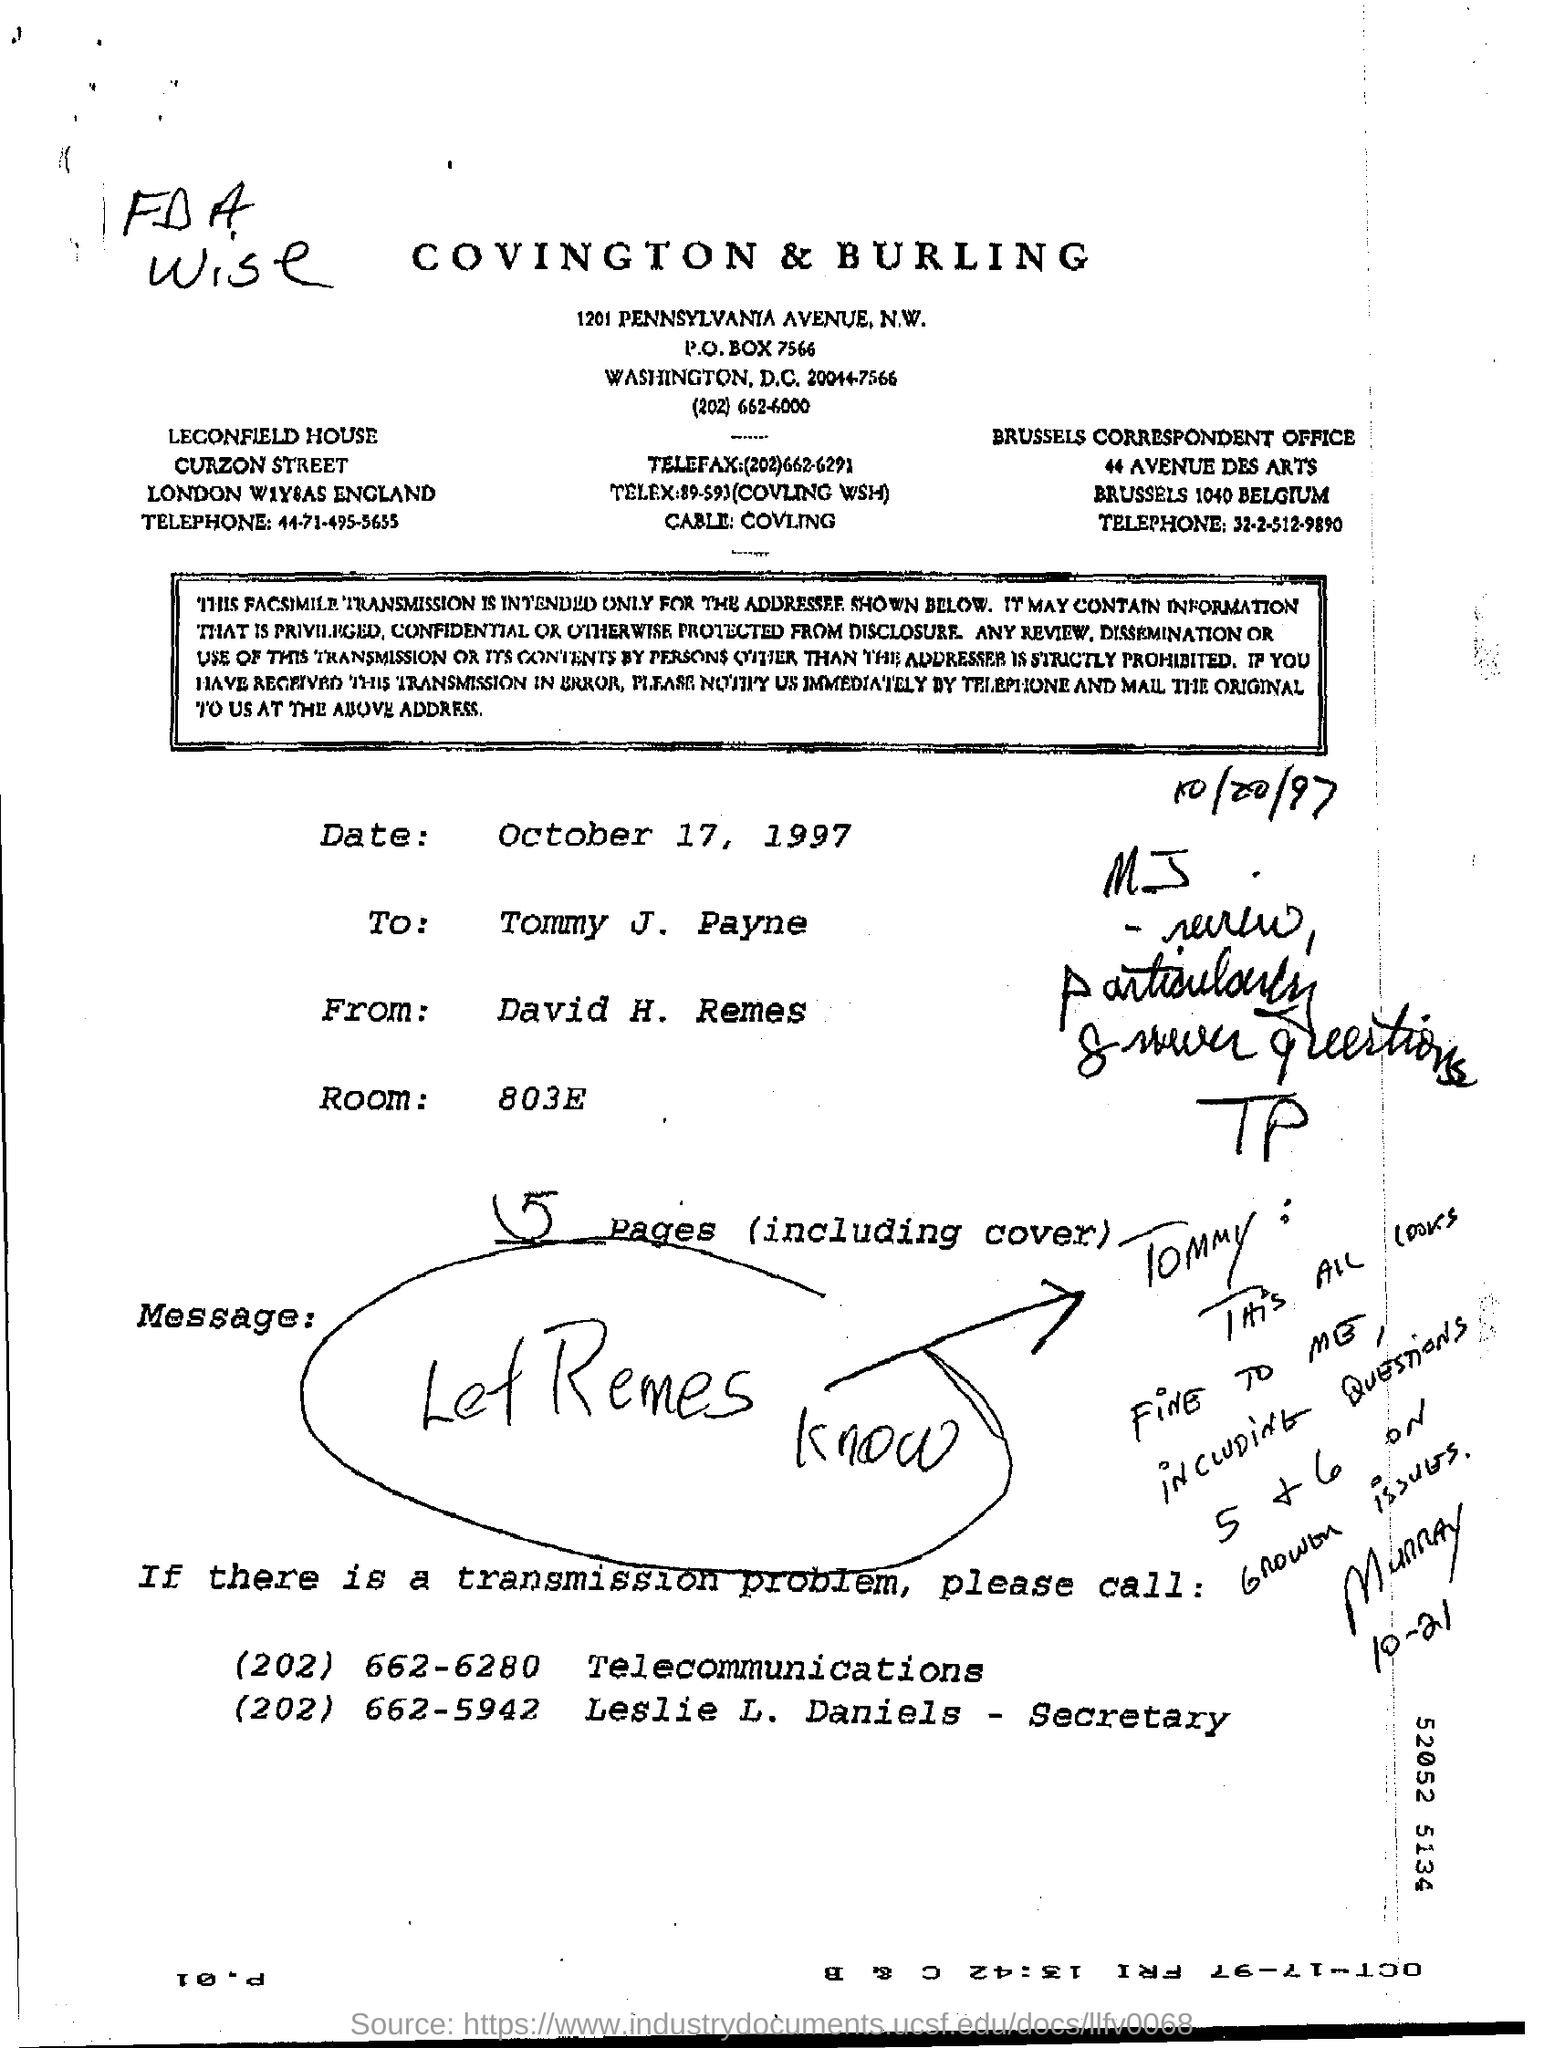What is the room no:?
Your answer should be compact. 803E. How many number of pages are there including cover page
Offer a very short reply. 5. 